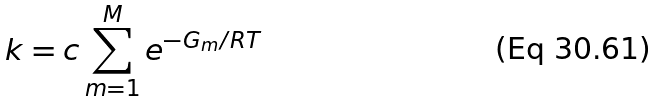<formula> <loc_0><loc_0><loc_500><loc_500>k = c \sum _ { m = 1 } ^ { M } e ^ { - G _ { m } / R T }</formula> 